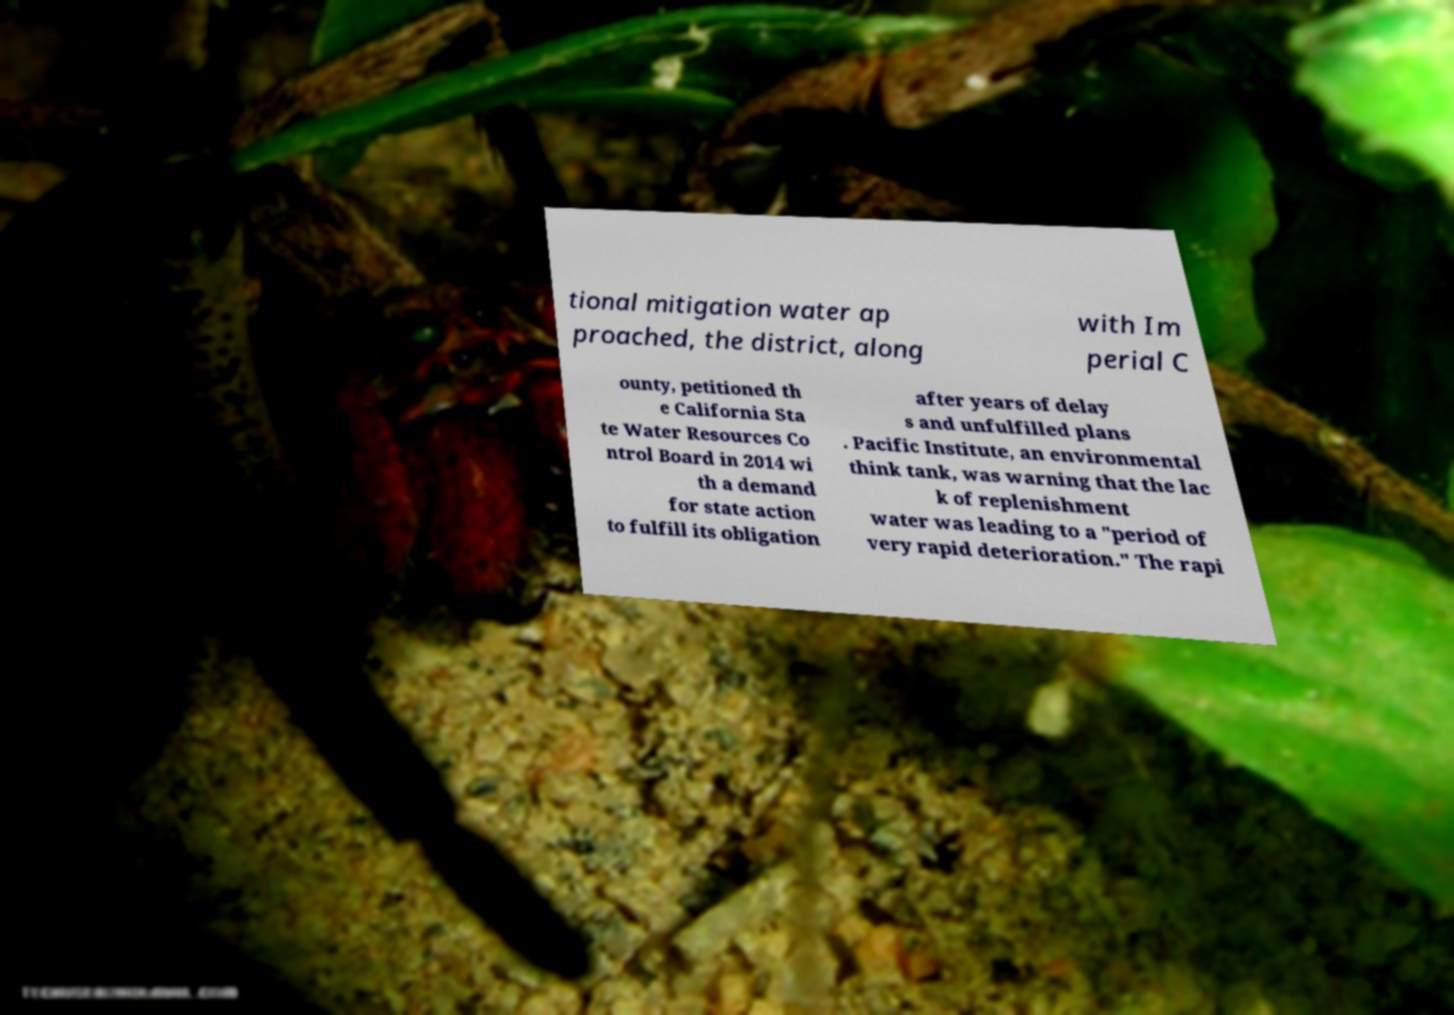Please read and relay the text visible in this image. What does it say? tional mitigation water ap proached, the district, along with Im perial C ounty, petitioned th e California Sta te Water Resources Co ntrol Board in 2014 wi th a demand for state action to fulfill its obligation after years of delay s and unfulfilled plans . Pacific Institute, an environmental think tank, was warning that the lac k of replenishment water was leading to a "period of very rapid deterioration." The rapi 